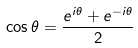Convert formula to latex. <formula><loc_0><loc_0><loc_500><loc_500>\cos \theta = \frac { e ^ { i \theta } + e ^ { - i \theta } } { 2 }</formula> 